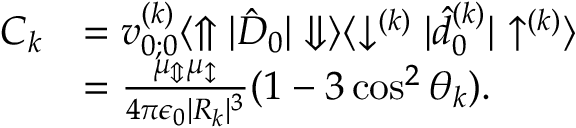Convert formula to latex. <formula><loc_0><loc_0><loc_500><loc_500>\begin{array} { r l } { C _ { k } } & { = v _ { 0 ; 0 } ^ { ( k ) } \langle \Uparrow | \hat { D } _ { 0 } | \Downarrow \rangle \langle \downarrow ^ { ( k ) } | \hat { d } _ { 0 } ^ { ( k ) } | \uparrow ^ { ( k ) } \rangle } \\ & { = \frac { \mu _ { \Updownarrow } \mu _ { \updownarrow } } { 4 \pi \epsilon _ { 0 } | R _ { k } | ^ { 3 } } ( 1 - 3 \cos ^ { 2 } \theta _ { k } ) . } \end{array}</formula> 